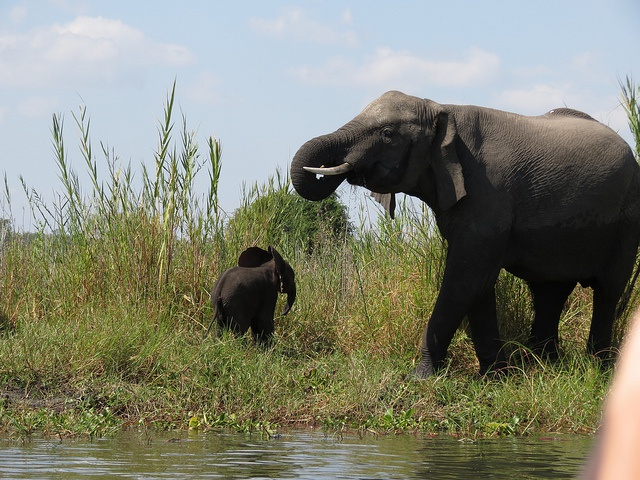Describe the objects in this image and their specific colors. I can see elephant in lightblue, black, gray, darkgray, and darkgreen tones and elephant in lightblue, black, darkgreen, and gray tones in this image. 